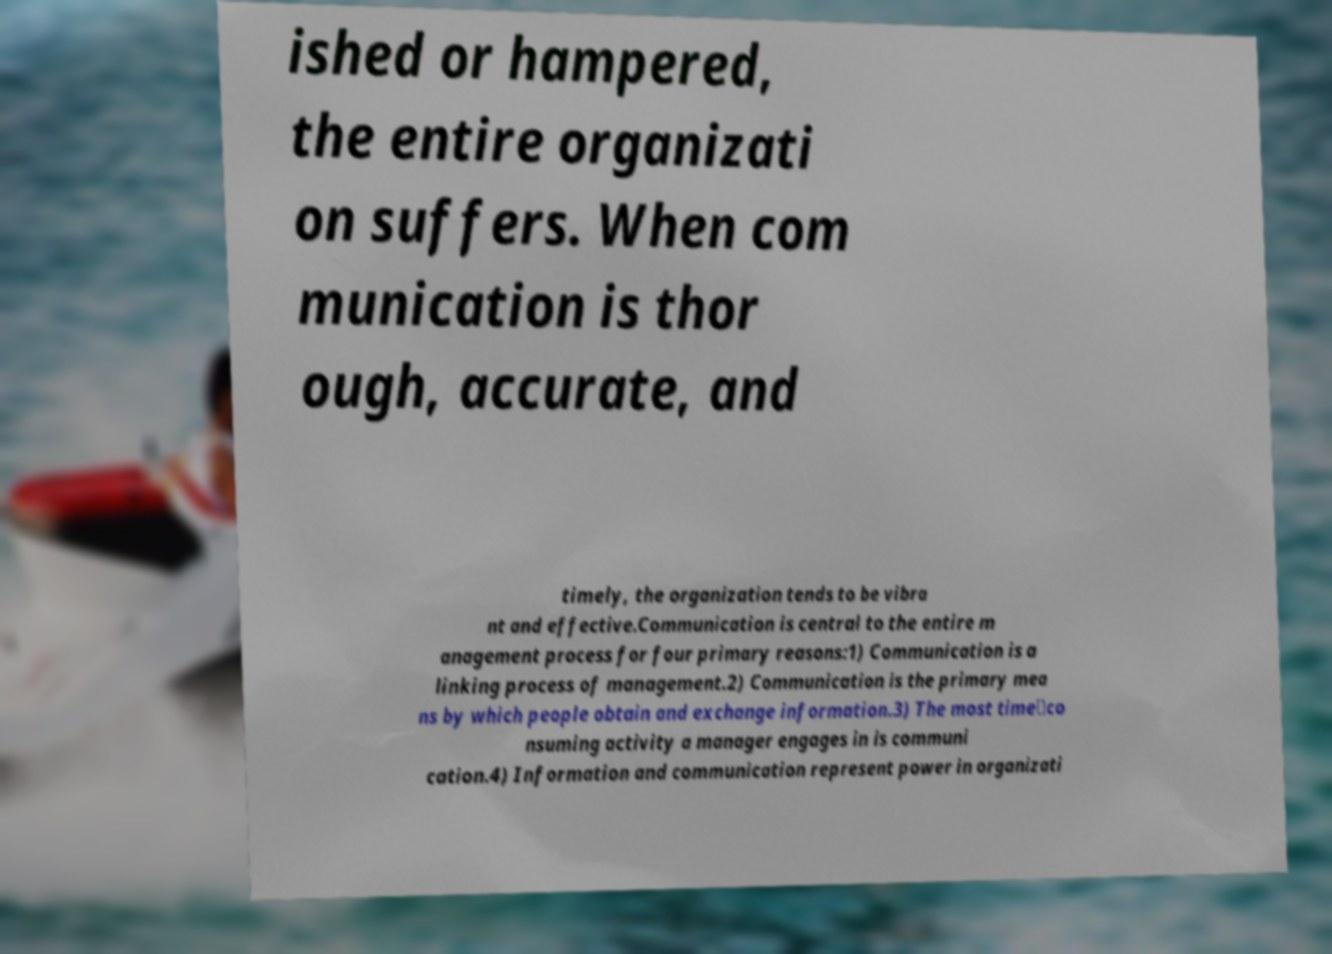I need the written content from this picture converted into text. Can you do that? ished or hampered, the entire organizati on suffers. When com munication is thor ough, accurate, and timely, the organization tends to be vibra nt and effective.Communication is central to the entire m anagement process for four primary reasons:1) Communication is a linking process of management.2) Communication is the primary mea ns by which people obtain and exchange information.3) The most time‐co nsuming activity a manager engages in is communi cation.4) Information and communication represent power in organizati 